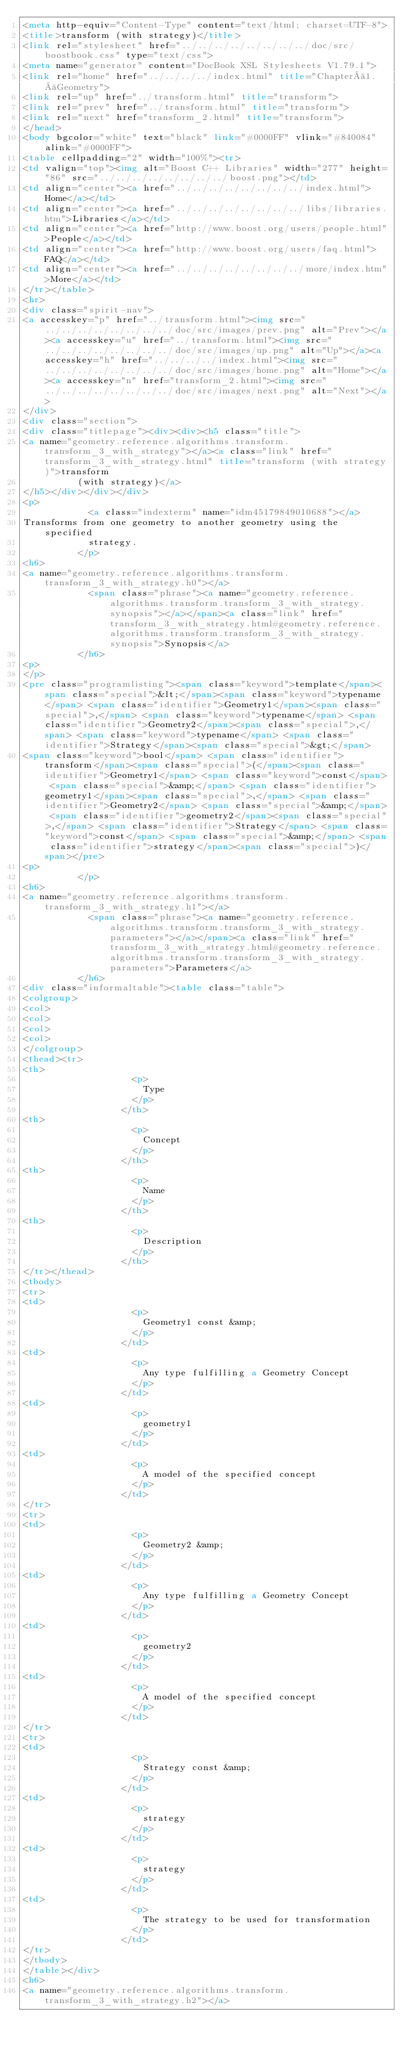Convert code to text. <code><loc_0><loc_0><loc_500><loc_500><_HTML_><meta http-equiv="Content-Type" content="text/html; charset=UTF-8">
<title>transform (with strategy)</title>
<link rel="stylesheet" href="../../../../../../../../doc/src/boostbook.css" type="text/css">
<meta name="generator" content="DocBook XSL Stylesheets V1.79.1">
<link rel="home" href="../../../../index.html" title="Chapter 1. Geometry">
<link rel="up" href="../transform.html" title="transform">
<link rel="prev" href="../transform.html" title="transform">
<link rel="next" href="transform_2.html" title="transform">
</head>
<body bgcolor="white" text="black" link="#0000FF" vlink="#840084" alink="#0000FF">
<table cellpadding="2" width="100%"><tr>
<td valign="top"><img alt="Boost C++ Libraries" width="277" height="86" src="../../../../../../../../boost.png"></td>
<td align="center"><a href="../../../../../../../../index.html">Home</a></td>
<td align="center"><a href="../../../../../../../../libs/libraries.htm">Libraries</a></td>
<td align="center"><a href="http://www.boost.org/users/people.html">People</a></td>
<td align="center"><a href="http://www.boost.org/users/faq.html">FAQ</a></td>
<td align="center"><a href="../../../../../../../../more/index.htm">More</a></td>
</tr></table>
<hr>
<div class="spirit-nav">
<a accesskey="p" href="../transform.html"><img src="../../../../../../../../doc/src/images/prev.png" alt="Prev"></a><a accesskey="u" href="../transform.html"><img src="../../../../../../../../doc/src/images/up.png" alt="Up"></a><a accesskey="h" href="../../../../index.html"><img src="../../../../../../../../doc/src/images/home.png" alt="Home"></a><a accesskey="n" href="transform_2.html"><img src="../../../../../../../../doc/src/images/next.png" alt="Next"></a>
</div>
<div class="section">
<div class="titlepage"><div><div><h5 class="title">
<a name="geometry.reference.algorithms.transform.transform_3_with_strategy"></a><a class="link" href="transform_3_with_strategy.html" title="transform (with strategy)">transform
          (with strategy)</a>
</h5></div></div></div>
<p>
            <a class="indexterm" name="idm45179849010688"></a>
Transforms from one geometry to another geometry using the specified
            strategy.
          </p>
<h6>
<a name="geometry.reference.algorithms.transform.transform_3_with_strategy.h0"></a>
            <span class="phrase"><a name="geometry.reference.algorithms.transform.transform_3_with_strategy.synopsis"></a></span><a class="link" href="transform_3_with_strategy.html#geometry.reference.algorithms.transform.transform_3_with_strategy.synopsis">Synopsis</a>
          </h6>
<p>
</p>
<pre class="programlisting"><span class="keyword">template</span><span class="special">&lt;</span><span class="keyword">typename</span> <span class="identifier">Geometry1</span><span class="special">,</span> <span class="keyword">typename</span> <span class="identifier">Geometry2</span><span class="special">,</span> <span class="keyword">typename</span> <span class="identifier">Strategy</span><span class="special">&gt;</span>
<span class="keyword">bool</span> <span class="identifier">transform</span><span class="special">(</span><span class="identifier">Geometry1</span> <span class="keyword">const</span> <span class="special">&amp;</span> <span class="identifier">geometry1</span><span class="special">,</span> <span class="identifier">Geometry2</span> <span class="special">&amp;</span> <span class="identifier">geometry2</span><span class="special">,</span> <span class="identifier">Strategy</span> <span class="keyword">const</span> <span class="special">&amp;</span> <span class="identifier">strategy</span><span class="special">)</span></pre>
<p>
          </p>
<h6>
<a name="geometry.reference.algorithms.transform.transform_3_with_strategy.h1"></a>
            <span class="phrase"><a name="geometry.reference.algorithms.transform.transform_3_with_strategy.parameters"></a></span><a class="link" href="transform_3_with_strategy.html#geometry.reference.algorithms.transform.transform_3_with_strategy.parameters">Parameters</a>
          </h6>
<div class="informaltable"><table class="table">
<colgroup>
<col>
<col>
<col>
<col>
</colgroup>
<thead><tr>
<th>
                    <p>
                      Type
                    </p>
                  </th>
<th>
                    <p>
                      Concept
                    </p>
                  </th>
<th>
                    <p>
                      Name
                    </p>
                  </th>
<th>
                    <p>
                      Description
                    </p>
                  </th>
</tr></thead>
<tbody>
<tr>
<td>
                    <p>
                      Geometry1 const &amp;
                    </p>
                  </td>
<td>
                    <p>
                      Any type fulfilling a Geometry Concept
                    </p>
                  </td>
<td>
                    <p>
                      geometry1
                    </p>
                  </td>
<td>
                    <p>
                      A model of the specified concept
                    </p>
                  </td>
</tr>
<tr>
<td>
                    <p>
                      Geometry2 &amp;
                    </p>
                  </td>
<td>
                    <p>
                      Any type fulfilling a Geometry Concept
                    </p>
                  </td>
<td>
                    <p>
                      geometry2
                    </p>
                  </td>
<td>
                    <p>
                      A model of the specified concept
                    </p>
                  </td>
</tr>
<tr>
<td>
                    <p>
                      Strategy const &amp;
                    </p>
                  </td>
<td>
                    <p>
                      strategy
                    </p>
                  </td>
<td>
                    <p>
                      strategy
                    </p>
                  </td>
<td>
                    <p>
                      The strategy to be used for transformation
                    </p>
                  </td>
</tr>
</tbody>
</table></div>
<h6>
<a name="geometry.reference.algorithms.transform.transform_3_with_strategy.h2"></a></code> 